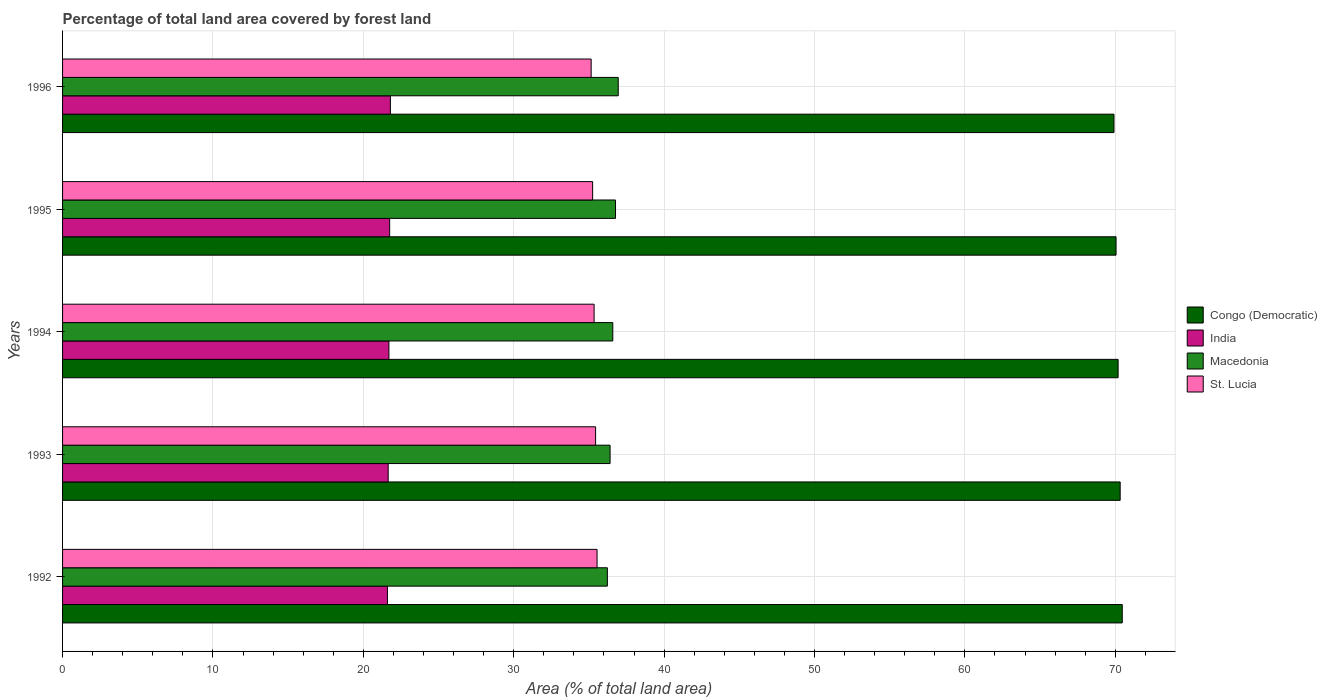How many different coloured bars are there?
Offer a terse response. 4. Are the number of bars per tick equal to the number of legend labels?
Ensure brevity in your answer.  Yes. How many bars are there on the 2nd tick from the top?
Offer a very short reply. 4. How many bars are there on the 3rd tick from the bottom?
Provide a short and direct response. 4. What is the percentage of forest land in India in 1993?
Ensure brevity in your answer.  21.65. Across all years, what is the maximum percentage of forest land in Macedonia?
Offer a very short reply. 36.95. Across all years, what is the minimum percentage of forest land in Congo (Democratic)?
Provide a succinct answer. 69.91. In which year was the percentage of forest land in St. Lucia minimum?
Make the answer very short. 1996. What is the total percentage of forest land in India in the graph?
Keep it short and to the point. 108.5. What is the difference between the percentage of forest land in India in 1994 and that in 1995?
Make the answer very short. -0.05. What is the difference between the percentage of forest land in St. Lucia in 1992 and the percentage of forest land in Congo (Democratic) in 1995?
Offer a very short reply. -34.51. What is the average percentage of forest land in Macedonia per year?
Ensure brevity in your answer.  36.59. In the year 1994, what is the difference between the percentage of forest land in Congo (Democratic) and percentage of forest land in Macedonia?
Make the answer very short. 33.6. What is the ratio of the percentage of forest land in Congo (Democratic) in 1992 to that in 1995?
Provide a succinct answer. 1.01. Is the percentage of forest land in India in 1992 less than that in 1993?
Offer a terse response. Yes. What is the difference between the highest and the second highest percentage of forest land in India?
Make the answer very short. 0.05. What is the difference between the highest and the lowest percentage of forest land in Macedonia?
Your answer should be very brief. 0.72. Is it the case that in every year, the sum of the percentage of forest land in India and percentage of forest land in St. Lucia is greater than the sum of percentage of forest land in Congo (Democratic) and percentage of forest land in Macedonia?
Give a very brief answer. No. What does the 4th bar from the bottom in 1992 represents?
Ensure brevity in your answer.  St. Lucia. Is it the case that in every year, the sum of the percentage of forest land in India and percentage of forest land in St. Lucia is greater than the percentage of forest land in Macedonia?
Your answer should be very brief. Yes. Are all the bars in the graph horizontal?
Offer a very short reply. Yes. How many years are there in the graph?
Keep it short and to the point. 5. What is the difference between two consecutive major ticks on the X-axis?
Keep it short and to the point. 10. Does the graph contain any zero values?
Provide a short and direct response. No. How many legend labels are there?
Your answer should be compact. 4. What is the title of the graph?
Your answer should be compact. Percentage of total land area covered by forest land. What is the label or title of the X-axis?
Your answer should be very brief. Area (% of total land area). What is the Area (% of total land area) of Congo (Democratic) in 1992?
Ensure brevity in your answer.  70.46. What is the Area (% of total land area) of India in 1992?
Your answer should be compact. 21.6. What is the Area (% of total land area) in Macedonia in 1992?
Keep it short and to the point. 36.22. What is the Area (% of total land area) of St. Lucia in 1992?
Your answer should be very brief. 35.54. What is the Area (% of total land area) in Congo (Democratic) in 1993?
Your response must be concise. 70.32. What is the Area (% of total land area) of India in 1993?
Offer a terse response. 21.65. What is the Area (% of total land area) of Macedonia in 1993?
Provide a short and direct response. 36.41. What is the Area (% of total land area) in St. Lucia in 1993?
Provide a short and direct response. 35.44. What is the Area (% of total land area) of Congo (Democratic) in 1994?
Give a very brief answer. 70.19. What is the Area (% of total land area) of India in 1994?
Ensure brevity in your answer.  21.7. What is the Area (% of total land area) in Macedonia in 1994?
Offer a very short reply. 36.59. What is the Area (% of total land area) of St. Lucia in 1994?
Give a very brief answer. 35.34. What is the Area (% of total land area) in Congo (Democratic) in 1995?
Provide a short and direct response. 70.05. What is the Area (% of total land area) of India in 1995?
Keep it short and to the point. 21.75. What is the Area (% of total land area) in Macedonia in 1995?
Ensure brevity in your answer.  36.77. What is the Area (% of total land area) in St. Lucia in 1995?
Offer a very short reply. 35.25. What is the Area (% of total land area) of Congo (Democratic) in 1996?
Offer a very short reply. 69.91. What is the Area (% of total land area) of India in 1996?
Make the answer very short. 21.8. What is the Area (% of total land area) of Macedonia in 1996?
Provide a short and direct response. 36.95. What is the Area (% of total land area) of St. Lucia in 1996?
Give a very brief answer. 35.15. Across all years, what is the maximum Area (% of total land area) in Congo (Democratic)?
Make the answer very short. 70.46. Across all years, what is the maximum Area (% of total land area) of India?
Keep it short and to the point. 21.8. Across all years, what is the maximum Area (% of total land area) of Macedonia?
Your response must be concise. 36.95. Across all years, what is the maximum Area (% of total land area) of St. Lucia?
Provide a short and direct response. 35.54. Across all years, what is the minimum Area (% of total land area) of Congo (Democratic)?
Your answer should be very brief. 69.91. Across all years, what is the minimum Area (% of total land area) of India?
Keep it short and to the point. 21.6. Across all years, what is the minimum Area (% of total land area) in Macedonia?
Keep it short and to the point. 36.22. Across all years, what is the minimum Area (% of total land area) of St. Lucia?
Offer a very short reply. 35.15. What is the total Area (% of total land area) of Congo (Democratic) in the graph?
Your answer should be very brief. 350.93. What is the total Area (% of total land area) of India in the graph?
Provide a short and direct response. 108.5. What is the total Area (% of total land area) in Macedonia in the graph?
Ensure brevity in your answer.  182.93. What is the total Area (% of total land area) in St. Lucia in the graph?
Your response must be concise. 176.72. What is the difference between the Area (% of total land area) in Congo (Democratic) in 1992 and that in 1993?
Provide a short and direct response. 0.14. What is the difference between the Area (% of total land area) in India in 1992 and that in 1993?
Offer a terse response. -0.05. What is the difference between the Area (% of total land area) of Macedonia in 1992 and that in 1993?
Ensure brevity in your answer.  -0.18. What is the difference between the Area (% of total land area) in St. Lucia in 1992 and that in 1993?
Provide a succinct answer. 0.1. What is the difference between the Area (% of total land area) of Congo (Democratic) in 1992 and that in 1994?
Provide a succinct answer. 0.27. What is the difference between the Area (% of total land area) of India in 1992 and that in 1994?
Provide a short and direct response. -0.1. What is the difference between the Area (% of total land area) of Macedonia in 1992 and that in 1994?
Keep it short and to the point. -0.36. What is the difference between the Area (% of total land area) in St. Lucia in 1992 and that in 1994?
Your answer should be compact. 0.2. What is the difference between the Area (% of total land area) of Congo (Democratic) in 1992 and that in 1995?
Give a very brief answer. 0.41. What is the difference between the Area (% of total land area) in India in 1992 and that in 1995?
Your answer should be very brief. -0.15. What is the difference between the Area (% of total land area) of Macedonia in 1992 and that in 1995?
Your answer should be compact. -0.54. What is the difference between the Area (% of total land area) of St. Lucia in 1992 and that in 1995?
Make the answer very short. 0.3. What is the difference between the Area (% of total land area) of Congo (Democratic) in 1992 and that in 1996?
Provide a short and direct response. 0.55. What is the difference between the Area (% of total land area) in India in 1992 and that in 1996?
Ensure brevity in your answer.  -0.2. What is the difference between the Area (% of total land area) of Macedonia in 1992 and that in 1996?
Keep it short and to the point. -0.72. What is the difference between the Area (% of total land area) in St. Lucia in 1992 and that in 1996?
Offer a terse response. 0.39. What is the difference between the Area (% of total land area) of Congo (Democratic) in 1993 and that in 1994?
Keep it short and to the point. 0.14. What is the difference between the Area (% of total land area) of India in 1993 and that in 1994?
Ensure brevity in your answer.  -0.05. What is the difference between the Area (% of total land area) of Macedonia in 1993 and that in 1994?
Ensure brevity in your answer.  -0.18. What is the difference between the Area (% of total land area) of St. Lucia in 1993 and that in 1994?
Provide a succinct answer. 0.1. What is the difference between the Area (% of total land area) in Congo (Democratic) in 1993 and that in 1995?
Keep it short and to the point. 0.27. What is the difference between the Area (% of total land area) of India in 1993 and that in 1995?
Provide a short and direct response. -0.1. What is the difference between the Area (% of total land area) in Macedonia in 1993 and that in 1995?
Keep it short and to the point. -0.36. What is the difference between the Area (% of total land area) in St. Lucia in 1993 and that in 1995?
Offer a very short reply. 0.2. What is the difference between the Area (% of total land area) of Congo (Democratic) in 1993 and that in 1996?
Make the answer very short. 0.41. What is the difference between the Area (% of total land area) of India in 1993 and that in 1996?
Offer a very short reply. -0.15. What is the difference between the Area (% of total land area) of Macedonia in 1993 and that in 1996?
Make the answer very short. -0.54. What is the difference between the Area (% of total land area) of St. Lucia in 1993 and that in 1996?
Provide a short and direct response. 0.3. What is the difference between the Area (% of total land area) of Congo (Democratic) in 1994 and that in 1995?
Make the answer very short. 0.14. What is the difference between the Area (% of total land area) of India in 1994 and that in 1995?
Your response must be concise. -0.05. What is the difference between the Area (% of total land area) in Macedonia in 1994 and that in 1995?
Offer a very short reply. -0.18. What is the difference between the Area (% of total land area) of St. Lucia in 1994 and that in 1995?
Give a very brief answer. 0.1. What is the difference between the Area (% of total land area) in Congo (Democratic) in 1994 and that in 1996?
Keep it short and to the point. 0.27. What is the difference between the Area (% of total land area) of India in 1994 and that in 1996?
Provide a succinct answer. -0.1. What is the difference between the Area (% of total land area) in Macedonia in 1994 and that in 1996?
Provide a succinct answer. -0.36. What is the difference between the Area (% of total land area) of St. Lucia in 1994 and that in 1996?
Provide a succinct answer. 0.2. What is the difference between the Area (% of total land area) of Congo (Democratic) in 1995 and that in 1996?
Give a very brief answer. 0.14. What is the difference between the Area (% of total land area) in India in 1995 and that in 1996?
Ensure brevity in your answer.  -0.05. What is the difference between the Area (% of total land area) of Macedonia in 1995 and that in 1996?
Your answer should be compact. -0.18. What is the difference between the Area (% of total land area) in St. Lucia in 1995 and that in 1996?
Your response must be concise. 0.1. What is the difference between the Area (% of total land area) in Congo (Democratic) in 1992 and the Area (% of total land area) in India in 1993?
Provide a succinct answer. 48.81. What is the difference between the Area (% of total land area) in Congo (Democratic) in 1992 and the Area (% of total land area) in Macedonia in 1993?
Give a very brief answer. 34.06. What is the difference between the Area (% of total land area) of Congo (Democratic) in 1992 and the Area (% of total land area) of St. Lucia in 1993?
Provide a succinct answer. 35.02. What is the difference between the Area (% of total land area) in India in 1992 and the Area (% of total land area) in Macedonia in 1993?
Your response must be concise. -14.8. What is the difference between the Area (% of total land area) of India in 1992 and the Area (% of total land area) of St. Lucia in 1993?
Your answer should be compact. -13.84. What is the difference between the Area (% of total land area) of Macedonia in 1992 and the Area (% of total land area) of St. Lucia in 1993?
Offer a terse response. 0.78. What is the difference between the Area (% of total land area) of Congo (Democratic) in 1992 and the Area (% of total land area) of India in 1994?
Your answer should be compact. 48.76. What is the difference between the Area (% of total land area) in Congo (Democratic) in 1992 and the Area (% of total land area) in Macedonia in 1994?
Offer a terse response. 33.88. What is the difference between the Area (% of total land area) in Congo (Democratic) in 1992 and the Area (% of total land area) in St. Lucia in 1994?
Your answer should be compact. 35.12. What is the difference between the Area (% of total land area) in India in 1992 and the Area (% of total land area) in Macedonia in 1994?
Offer a terse response. -14.98. What is the difference between the Area (% of total land area) in India in 1992 and the Area (% of total land area) in St. Lucia in 1994?
Ensure brevity in your answer.  -13.74. What is the difference between the Area (% of total land area) in Macedonia in 1992 and the Area (% of total land area) in St. Lucia in 1994?
Make the answer very short. 0.88. What is the difference between the Area (% of total land area) in Congo (Democratic) in 1992 and the Area (% of total land area) in India in 1995?
Offer a terse response. 48.71. What is the difference between the Area (% of total land area) of Congo (Democratic) in 1992 and the Area (% of total land area) of Macedonia in 1995?
Your answer should be compact. 33.69. What is the difference between the Area (% of total land area) of Congo (Democratic) in 1992 and the Area (% of total land area) of St. Lucia in 1995?
Your answer should be compact. 35.22. What is the difference between the Area (% of total land area) of India in 1992 and the Area (% of total land area) of Macedonia in 1995?
Offer a very short reply. -15.16. What is the difference between the Area (% of total land area) of India in 1992 and the Area (% of total land area) of St. Lucia in 1995?
Offer a very short reply. -13.64. What is the difference between the Area (% of total land area) in Macedonia in 1992 and the Area (% of total land area) in St. Lucia in 1995?
Make the answer very short. 0.98. What is the difference between the Area (% of total land area) in Congo (Democratic) in 1992 and the Area (% of total land area) in India in 1996?
Provide a succinct answer. 48.66. What is the difference between the Area (% of total land area) of Congo (Democratic) in 1992 and the Area (% of total land area) of Macedonia in 1996?
Ensure brevity in your answer.  33.51. What is the difference between the Area (% of total land area) of Congo (Democratic) in 1992 and the Area (% of total land area) of St. Lucia in 1996?
Make the answer very short. 35.31. What is the difference between the Area (% of total land area) in India in 1992 and the Area (% of total land area) in Macedonia in 1996?
Provide a short and direct response. -15.35. What is the difference between the Area (% of total land area) in India in 1992 and the Area (% of total land area) in St. Lucia in 1996?
Provide a short and direct response. -13.54. What is the difference between the Area (% of total land area) of Macedonia in 1992 and the Area (% of total land area) of St. Lucia in 1996?
Your answer should be very brief. 1.08. What is the difference between the Area (% of total land area) in Congo (Democratic) in 1993 and the Area (% of total land area) in India in 1994?
Offer a terse response. 48.62. What is the difference between the Area (% of total land area) of Congo (Democratic) in 1993 and the Area (% of total land area) of Macedonia in 1994?
Offer a very short reply. 33.74. What is the difference between the Area (% of total land area) of Congo (Democratic) in 1993 and the Area (% of total land area) of St. Lucia in 1994?
Your answer should be very brief. 34.98. What is the difference between the Area (% of total land area) of India in 1993 and the Area (% of total land area) of Macedonia in 1994?
Provide a short and direct response. -14.94. What is the difference between the Area (% of total land area) in India in 1993 and the Area (% of total land area) in St. Lucia in 1994?
Ensure brevity in your answer.  -13.69. What is the difference between the Area (% of total land area) of Macedonia in 1993 and the Area (% of total land area) of St. Lucia in 1994?
Ensure brevity in your answer.  1.06. What is the difference between the Area (% of total land area) of Congo (Democratic) in 1993 and the Area (% of total land area) of India in 1995?
Offer a terse response. 48.58. What is the difference between the Area (% of total land area) in Congo (Democratic) in 1993 and the Area (% of total land area) in Macedonia in 1995?
Give a very brief answer. 33.56. What is the difference between the Area (% of total land area) in Congo (Democratic) in 1993 and the Area (% of total land area) in St. Lucia in 1995?
Provide a short and direct response. 35.08. What is the difference between the Area (% of total land area) in India in 1993 and the Area (% of total land area) in Macedonia in 1995?
Keep it short and to the point. -15.12. What is the difference between the Area (% of total land area) in India in 1993 and the Area (% of total land area) in St. Lucia in 1995?
Keep it short and to the point. -13.59. What is the difference between the Area (% of total land area) of Macedonia in 1993 and the Area (% of total land area) of St. Lucia in 1995?
Ensure brevity in your answer.  1.16. What is the difference between the Area (% of total land area) of Congo (Democratic) in 1993 and the Area (% of total land area) of India in 1996?
Your response must be concise. 48.53. What is the difference between the Area (% of total land area) of Congo (Democratic) in 1993 and the Area (% of total land area) of Macedonia in 1996?
Keep it short and to the point. 33.38. What is the difference between the Area (% of total land area) of Congo (Democratic) in 1993 and the Area (% of total land area) of St. Lucia in 1996?
Your response must be concise. 35.18. What is the difference between the Area (% of total land area) in India in 1993 and the Area (% of total land area) in Macedonia in 1996?
Ensure brevity in your answer.  -15.3. What is the difference between the Area (% of total land area) in India in 1993 and the Area (% of total land area) in St. Lucia in 1996?
Your answer should be very brief. -13.5. What is the difference between the Area (% of total land area) in Macedonia in 1993 and the Area (% of total land area) in St. Lucia in 1996?
Provide a succinct answer. 1.26. What is the difference between the Area (% of total land area) in Congo (Democratic) in 1994 and the Area (% of total land area) in India in 1995?
Provide a succinct answer. 48.44. What is the difference between the Area (% of total land area) of Congo (Democratic) in 1994 and the Area (% of total land area) of Macedonia in 1995?
Your response must be concise. 33.42. What is the difference between the Area (% of total land area) of Congo (Democratic) in 1994 and the Area (% of total land area) of St. Lucia in 1995?
Give a very brief answer. 34.94. What is the difference between the Area (% of total land area) of India in 1994 and the Area (% of total land area) of Macedonia in 1995?
Give a very brief answer. -15.07. What is the difference between the Area (% of total land area) in India in 1994 and the Area (% of total land area) in St. Lucia in 1995?
Give a very brief answer. -13.55. What is the difference between the Area (% of total land area) of Macedonia in 1994 and the Area (% of total land area) of St. Lucia in 1995?
Provide a short and direct response. 1.34. What is the difference between the Area (% of total land area) in Congo (Democratic) in 1994 and the Area (% of total land area) in India in 1996?
Your answer should be very brief. 48.39. What is the difference between the Area (% of total land area) in Congo (Democratic) in 1994 and the Area (% of total land area) in Macedonia in 1996?
Offer a very short reply. 33.24. What is the difference between the Area (% of total land area) of Congo (Democratic) in 1994 and the Area (% of total land area) of St. Lucia in 1996?
Offer a terse response. 35.04. What is the difference between the Area (% of total land area) in India in 1994 and the Area (% of total land area) in Macedonia in 1996?
Provide a succinct answer. -15.25. What is the difference between the Area (% of total land area) in India in 1994 and the Area (% of total land area) in St. Lucia in 1996?
Offer a terse response. -13.45. What is the difference between the Area (% of total land area) of Macedonia in 1994 and the Area (% of total land area) of St. Lucia in 1996?
Your response must be concise. 1.44. What is the difference between the Area (% of total land area) in Congo (Democratic) in 1995 and the Area (% of total land area) in India in 1996?
Your response must be concise. 48.25. What is the difference between the Area (% of total land area) of Congo (Democratic) in 1995 and the Area (% of total land area) of Macedonia in 1996?
Make the answer very short. 33.1. What is the difference between the Area (% of total land area) of Congo (Democratic) in 1995 and the Area (% of total land area) of St. Lucia in 1996?
Your answer should be very brief. 34.9. What is the difference between the Area (% of total land area) of India in 1995 and the Area (% of total land area) of Macedonia in 1996?
Give a very brief answer. -15.2. What is the difference between the Area (% of total land area) of India in 1995 and the Area (% of total land area) of St. Lucia in 1996?
Provide a short and direct response. -13.4. What is the difference between the Area (% of total land area) of Macedonia in 1995 and the Area (% of total land area) of St. Lucia in 1996?
Offer a very short reply. 1.62. What is the average Area (% of total land area) of Congo (Democratic) per year?
Offer a very short reply. 70.19. What is the average Area (% of total land area) in India per year?
Make the answer very short. 21.7. What is the average Area (% of total land area) in Macedonia per year?
Your answer should be very brief. 36.59. What is the average Area (% of total land area) in St. Lucia per year?
Offer a terse response. 35.34. In the year 1992, what is the difference between the Area (% of total land area) in Congo (Democratic) and Area (% of total land area) in India?
Give a very brief answer. 48.86. In the year 1992, what is the difference between the Area (% of total land area) in Congo (Democratic) and Area (% of total land area) in Macedonia?
Make the answer very short. 34.24. In the year 1992, what is the difference between the Area (% of total land area) in Congo (Democratic) and Area (% of total land area) in St. Lucia?
Offer a terse response. 34.92. In the year 1992, what is the difference between the Area (% of total land area) of India and Area (% of total land area) of Macedonia?
Make the answer very short. -14.62. In the year 1992, what is the difference between the Area (% of total land area) of India and Area (% of total land area) of St. Lucia?
Your answer should be compact. -13.94. In the year 1992, what is the difference between the Area (% of total land area) in Macedonia and Area (% of total land area) in St. Lucia?
Offer a very short reply. 0.68. In the year 1993, what is the difference between the Area (% of total land area) of Congo (Democratic) and Area (% of total land area) of India?
Make the answer very short. 48.67. In the year 1993, what is the difference between the Area (% of total land area) of Congo (Democratic) and Area (% of total land area) of Macedonia?
Your response must be concise. 33.92. In the year 1993, what is the difference between the Area (% of total land area) of Congo (Democratic) and Area (% of total land area) of St. Lucia?
Offer a very short reply. 34.88. In the year 1993, what is the difference between the Area (% of total land area) of India and Area (% of total land area) of Macedonia?
Ensure brevity in your answer.  -14.75. In the year 1993, what is the difference between the Area (% of total land area) in India and Area (% of total land area) in St. Lucia?
Keep it short and to the point. -13.79. In the year 1993, what is the difference between the Area (% of total land area) in Macedonia and Area (% of total land area) in St. Lucia?
Offer a very short reply. 0.96. In the year 1994, what is the difference between the Area (% of total land area) of Congo (Democratic) and Area (% of total land area) of India?
Offer a terse response. 48.49. In the year 1994, what is the difference between the Area (% of total land area) in Congo (Democratic) and Area (% of total land area) in Macedonia?
Provide a short and direct response. 33.6. In the year 1994, what is the difference between the Area (% of total land area) in Congo (Democratic) and Area (% of total land area) in St. Lucia?
Offer a very short reply. 34.84. In the year 1994, what is the difference between the Area (% of total land area) of India and Area (% of total land area) of Macedonia?
Provide a succinct answer. -14.89. In the year 1994, what is the difference between the Area (% of total land area) in India and Area (% of total land area) in St. Lucia?
Offer a terse response. -13.64. In the year 1994, what is the difference between the Area (% of total land area) in Macedonia and Area (% of total land area) in St. Lucia?
Give a very brief answer. 1.24. In the year 1995, what is the difference between the Area (% of total land area) in Congo (Democratic) and Area (% of total land area) in India?
Your answer should be compact. 48.3. In the year 1995, what is the difference between the Area (% of total land area) of Congo (Democratic) and Area (% of total land area) of Macedonia?
Your response must be concise. 33.28. In the year 1995, what is the difference between the Area (% of total land area) of Congo (Democratic) and Area (% of total land area) of St. Lucia?
Your answer should be compact. 34.8. In the year 1995, what is the difference between the Area (% of total land area) in India and Area (% of total land area) in Macedonia?
Offer a very short reply. -15.02. In the year 1995, what is the difference between the Area (% of total land area) of India and Area (% of total land area) of St. Lucia?
Provide a short and direct response. -13.5. In the year 1995, what is the difference between the Area (% of total land area) in Macedonia and Area (% of total land area) in St. Lucia?
Provide a succinct answer. 1.52. In the year 1996, what is the difference between the Area (% of total land area) in Congo (Democratic) and Area (% of total land area) in India?
Your answer should be very brief. 48.11. In the year 1996, what is the difference between the Area (% of total land area) in Congo (Democratic) and Area (% of total land area) in Macedonia?
Provide a short and direct response. 32.96. In the year 1996, what is the difference between the Area (% of total land area) of Congo (Democratic) and Area (% of total land area) of St. Lucia?
Offer a very short reply. 34.76. In the year 1996, what is the difference between the Area (% of total land area) in India and Area (% of total land area) in Macedonia?
Your answer should be very brief. -15.15. In the year 1996, what is the difference between the Area (% of total land area) in India and Area (% of total land area) in St. Lucia?
Provide a short and direct response. -13.35. In the year 1996, what is the difference between the Area (% of total land area) of Macedonia and Area (% of total land area) of St. Lucia?
Give a very brief answer. 1.8. What is the ratio of the Area (% of total land area) in Congo (Democratic) in 1992 to that in 1993?
Your answer should be compact. 1. What is the ratio of the Area (% of total land area) of Macedonia in 1992 to that in 1993?
Your response must be concise. 0.99. What is the ratio of the Area (% of total land area) of St. Lucia in 1992 to that in 1993?
Offer a terse response. 1. What is the ratio of the Area (% of total land area) of India in 1992 to that in 1994?
Ensure brevity in your answer.  1. What is the ratio of the Area (% of total land area) of St. Lucia in 1992 to that in 1994?
Offer a terse response. 1.01. What is the ratio of the Area (% of total land area) in Congo (Democratic) in 1992 to that in 1995?
Keep it short and to the point. 1.01. What is the ratio of the Area (% of total land area) of India in 1992 to that in 1995?
Give a very brief answer. 0.99. What is the ratio of the Area (% of total land area) of Macedonia in 1992 to that in 1995?
Your answer should be very brief. 0.99. What is the ratio of the Area (% of total land area) in St. Lucia in 1992 to that in 1995?
Offer a very short reply. 1.01. What is the ratio of the Area (% of total land area) in Congo (Democratic) in 1992 to that in 1996?
Your answer should be compact. 1.01. What is the ratio of the Area (% of total land area) in Macedonia in 1992 to that in 1996?
Make the answer very short. 0.98. What is the ratio of the Area (% of total land area) of St. Lucia in 1992 to that in 1996?
Your response must be concise. 1.01. What is the ratio of the Area (% of total land area) of Congo (Democratic) in 1993 to that in 1994?
Your response must be concise. 1. What is the ratio of the Area (% of total land area) in Macedonia in 1993 to that in 1994?
Provide a succinct answer. 1. What is the ratio of the Area (% of total land area) of Congo (Democratic) in 1993 to that in 1995?
Your response must be concise. 1. What is the ratio of the Area (% of total land area) in India in 1993 to that in 1995?
Offer a terse response. 1. What is the ratio of the Area (% of total land area) in Macedonia in 1993 to that in 1995?
Provide a short and direct response. 0.99. What is the ratio of the Area (% of total land area) in St. Lucia in 1993 to that in 1995?
Offer a terse response. 1.01. What is the ratio of the Area (% of total land area) in Congo (Democratic) in 1993 to that in 1996?
Provide a short and direct response. 1.01. What is the ratio of the Area (% of total land area) of St. Lucia in 1993 to that in 1996?
Provide a succinct answer. 1.01. What is the ratio of the Area (% of total land area) of St. Lucia in 1994 to that in 1995?
Offer a very short reply. 1. What is the ratio of the Area (% of total land area) of India in 1994 to that in 1996?
Keep it short and to the point. 1. What is the ratio of the Area (% of total land area) in Macedonia in 1994 to that in 1996?
Your answer should be compact. 0.99. What is the ratio of the Area (% of total land area) of St. Lucia in 1994 to that in 1996?
Make the answer very short. 1.01. What is the ratio of the Area (% of total land area) of India in 1995 to that in 1996?
Give a very brief answer. 1. What is the ratio of the Area (% of total land area) of Macedonia in 1995 to that in 1996?
Your answer should be compact. 1. What is the ratio of the Area (% of total land area) in St. Lucia in 1995 to that in 1996?
Make the answer very short. 1. What is the difference between the highest and the second highest Area (% of total land area) in Congo (Democratic)?
Offer a very short reply. 0.14. What is the difference between the highest and the second highest Area (% of total land area) of India?
Your answer should be very brief. 0.05. What is the difference between the highest and the second highest Area (% of total land area) in Macedonia?
Your response must be concise. 0.18. What is the difference between the highest and the second highest Area (% of total land area) in St. Lucia?
Provide a short and direct response. 0.1. What is the difference between the highest and the lowest Area (% of total land area) in Congo (Democratic)?
Provide a succinct answer. 0.55. What is the difference between the highest and the lowest Area (% of total land area) in India?
Give a very brief answer. 0.2. What is the difference between the highest and the lowest Area (% of total land area) of Macedonia?
Provide a short and direct response. 0.72. What is the difference between the highest and the lowest Area (% of total land area) in St. Lucia?
Provide a succinct answer. 0.39. 